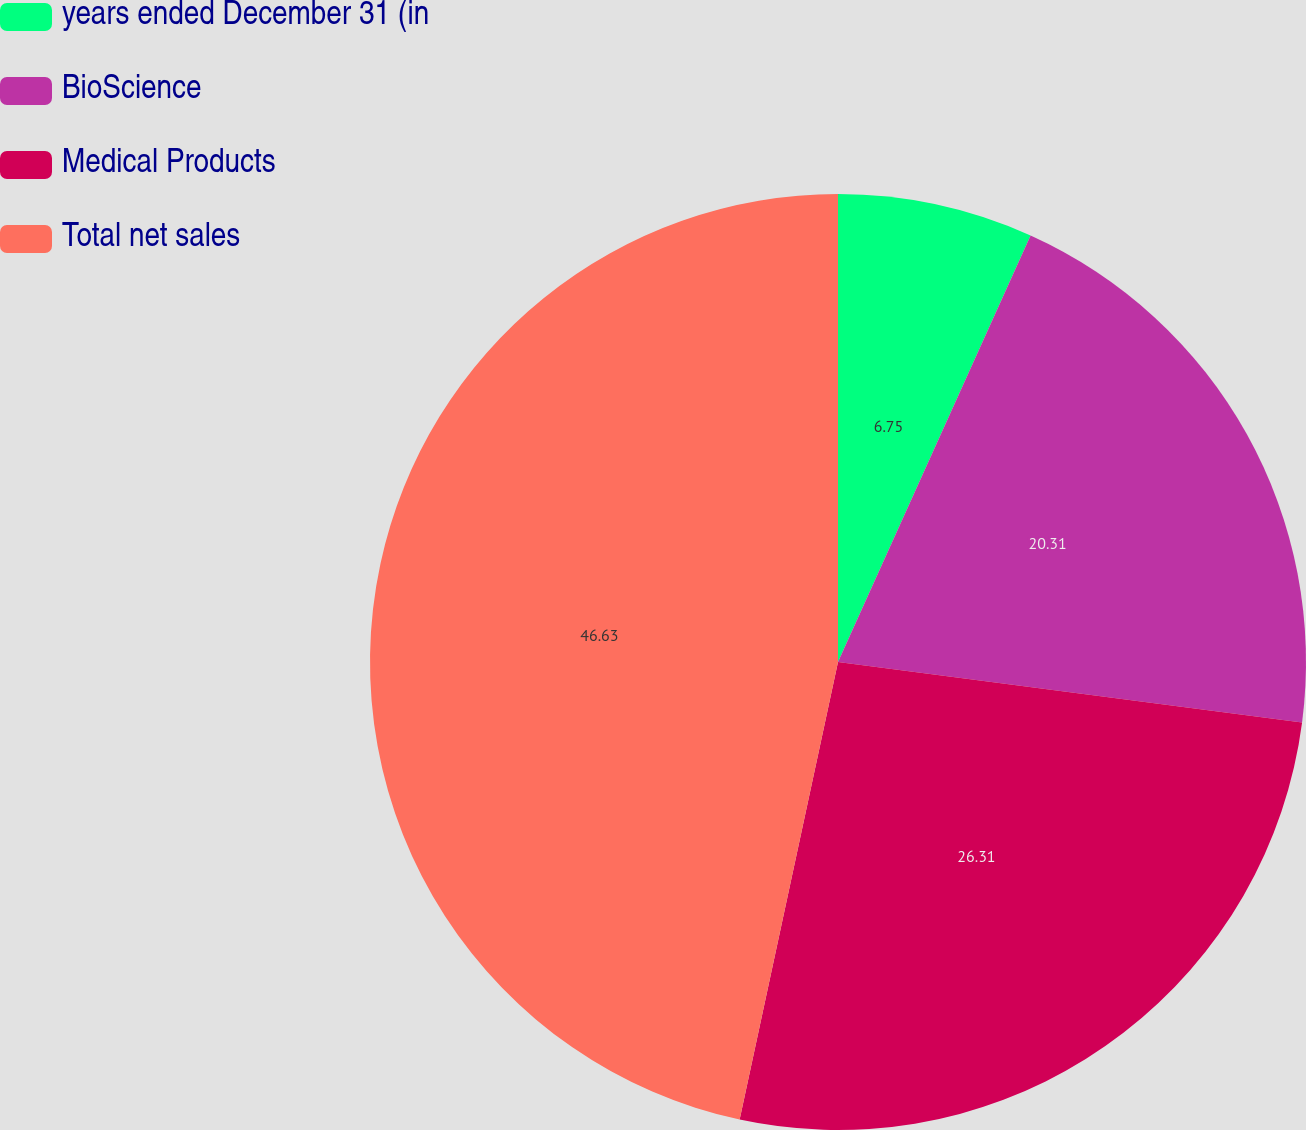Convert chart. <chart><loc_0><loc_0><loc_500><loc_500><pie_chart><fcel>years ended December 31 (in<fcel>BioScience<fcel>Medical Products<fcel>Total net sales<nl><fcel>6.75%<fcel>20.31%<fcel>26.31%<fcel>46.63%<nl></chart> 